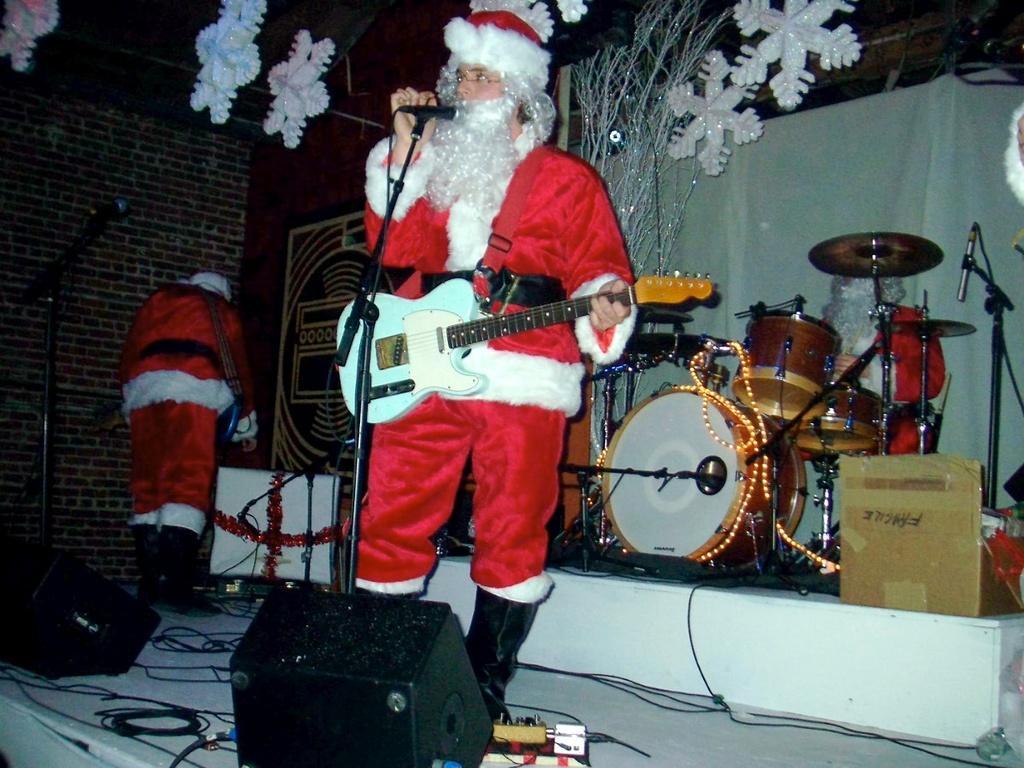Please provide a concise description of this image. In this image, few peoples are playing a musical instrument and the middle person is holding a microphone. The left side, person is standing here. We can see so many items on the stage. Backside we can see white curtain, some showpiece and brick wall at the left side. 